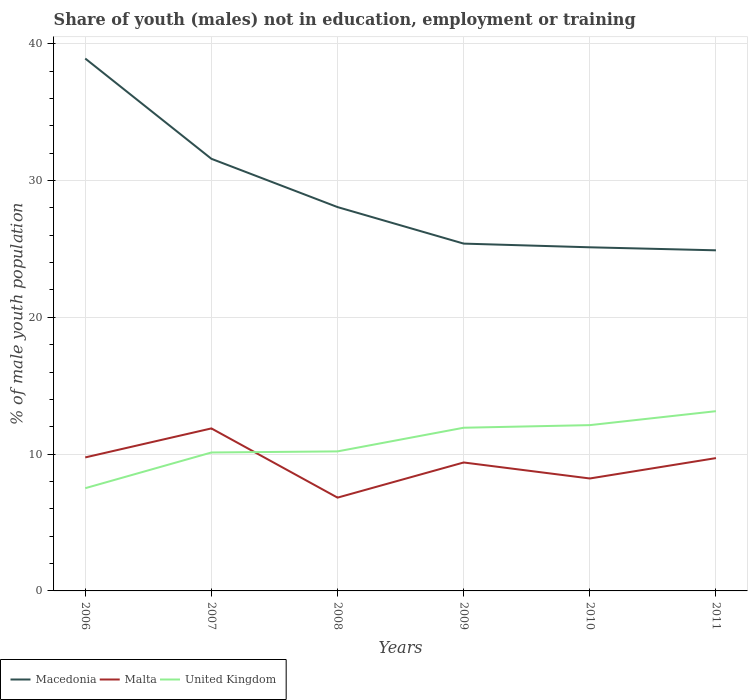Is the number of lines equal to the number of legend labels?
Make the answer very short. Yes. Across all years, what is the maximum percentage of unemployed males population in in Macedonia?
Your answer should be compact. 24.9. What is the total percentage of unemployed males population in in United Kingdom in the graph?
Offer a very short reply. -1.81. What is the difference between the highest and the second highest percentage of unemployed males population in in Macedonia?
Offer a terse response. 14.02. How many legend labels are there?
Provide a short and direct response. 3. What is the title of the graph?
Your response must be concise. Share of youth (males) not in education, employment or training. What is the label or title of the X-axis?
Ensure brevity in your answer.  Years. What is the label or title of the Y-axis?
Provide a short and direct response. % of male youth population. What is the % of male youth population of Macedonia in 2006?
Provide a succinct answer. 38.92. What is the % of male youth population in Malta in 2006?
Offer a terse response. 9.76. What is the % of male youth population in United Kingdom in 2006?
Provide a short and direct response. 7.51. What is the % of male youth population of Macedonia in 2007?
Ensure brevity in your answer.  31.59. What is the % of male youth population in Malta in 2007?
Your answer should be compact. 11.88. What is the % of male youth population of United Kingdom in 2007?
Ensure brevity in your answer.  10.12. What is the % of male youth population of Macedonia in 2008?
Ensure brevity in your answer.  28.06. What is the % of male youth population of Malta in 2008?
Your answer should be very brief. 6.82. What is the % of male youth population of United Kingdom in 2008?
Ensure brevity in your answer.  10.2. What is the % of male youth population in Macedonia in 2009?
Offer a terse response. 25.39. What is the % of male youth population in Malta in 2009?
Ensure brevity in your answer.  9.39. What is the % of male youth population in United Kingdom in 2009?
Your answer should be compact. 11.93. What is the % of male youth population of Macedonia in 2010?
Give a very brief answer. 25.12. What is the % of male youth population of Malta in 2010?
Offer a terse response. 8.22. What is the % of male youth population in United Kingdom in 2010?
Provide a short and direct response. 12.12. What is the % of male youth population in Macedonia in 2011?
Ensure brevity in your answer.  24.9. What is the % of male youth population in Malta in 2011?
Ensure brevity in your answer.  9.71. What is the % of male youth population of United Kingdom in 2011?
Offer a very short reply. 13.14. Across all years, what is the maximum % of male youth population in Macedonia?
Ensure brevity in your answer.  38.92. Across all years, what is the maximum % of male youth population of Malta?
Your answer should be compact. 11.88. Across all years, what is the maximum % of male youth population in United Kingdom?
Give a very brief answer. 13.14. Across all years, what is the minimum % of male youth population of Macedonia?
Your answer should be very brief. 24.9. Across all years, what is the minimum % of male youth population of Malta?
Your answer should be compact. 6.82. Across all years, what is the minimum % of male youth population of United Kingdom?
Provide a short and direct response. 7.51. What is the total % of male youth population of Macedonia in the graph?
Your response must be concise. 173.98. What is the total % of male youth population of Malta in the graph?
Your response must be concise. 55.78. What is the total % of male youth population of United Kingdom in the graph?
Your answer should be very brief. 65.02. What is the difference between the % of male youth population of Macedonia in 2006 and that in 2007?
Provide a succinct answer. 7.33. What is the difference between the % of male youth population of Malta in 2006 and that in 2007?
Ensure brevity in your answer.  -2.12. What is the difference between the % of male youth population in United Kingdom in 2006 and that in 2007?
Provide a short and direct response. -2.61. What is the difference between the % of male youth population of Macedonia in 2006 and that in 2008?
Ensure brevity in your answer.  10.86. What is the difference between the % of male youth population in Malta in 2006 and that in 2008?
Provide a short and direct response. 2.94. What is the difference between the % of male youth population of United Kingdom in 2006 and that in 2008?
Your response must be concise. -2.69. What is the difference between the % of male youth population in Macedonia in 2006 and that in 2009?
Your answer should be very brief. 13.53. What is the difference between the % of male youth population in Malta in 2006 and that in 2009?
Provide a succinct answer. 0.37. What is the difference between the % of male youth population in United Kingdom in 2006 and that in 2009?
Provide a short and direct response. -4.42. What is the difference between the % of male youth population in Macedonia in 2006 and that in 2010?
Your answer should be very brief. 13.8. What is the difference between the % of male youth population of Malta in 2006 and that in 2010?
Provide a short and direct response. 1.54. What is the difference between the % of male youth population of United Kingdom in 2006 and that in 2010?
Give a very brief answer. -4.61. What is the difference between the % of male youth population in Macedonia in 2006 and that in 2011?
Your response must be concise. 14.02. What is the difference between the % of male youth population in United Kingdom in 2006 and that in 2011?
Your response must be concise. -5.63. What is the difference between the % of male youth population in Macedonia in 2007 and that in 2008?
Your answer should be very brief. 3.53. What is the difference between the % of male youth population of Malta in 2007 and that in 2008?
Offer a very short reply. 5.06. What is the difference between the % of male youth population of United Kingdom in 2007 and that in 2008?
Keep it short and to the point. -0.08. What is the difference between the % of male youth population of Macedonia in 2007 and that in 2009?
Your response must be concise. 6.2. What is the difference between the % of male youth population of Malta in 2007 and that in 2009?
Offer a terse response. 2.49. What is the difference between the % of male youth population in United Kingdom in 2007 and that in 2009?
Make the answer very short. -1.81. What is the difference between the % of male youth population of Macedonia in 2007 and that in 2010?
Ensure brevity in your answer.  6.47. What is the difference between the % of male youth population in Malta in 2007 and that in 2010?
Give a very brief answer. 3.66. What is the difference between the % of male youth population of Macedonia in 2007 and that in 2011?
Offer a very short reply. 6.69. What is the difference between the % of male youth population in Malta in 2007 and that in 2011?
Keep it short and to the point. 2.17. What is the difference between the % of male youth population in United Kingdom in 2007 and that in 2011?
Offer a terse response. -3.02. What is the difference between the % of male youth population of Macedonia in 2008 and that in 2009?
Your answer should be compact. 2.67. What is the difference between the % of male youth population of Malta in 2008 and that in 2009?
Provide a succinct answer. -2.57. What is the difference between the % of male youth population of United Kingdom in 2008 and that in 2009?
Offer a terse response. -1.73. What is the difference between the % of male youth population in Macedonia in 2008 and that in 2010?
Provide a short and direct response. 2.94. What is the difference between the % of male youth population of Malta in 2008 and that in 2010?
Make the answer very short. -1.4. What is the difference between the % of male youth population of United Kingdom in 2008 and that in 2010?
Provide a succinct answer. -1.92. What is the difference between the % of male youth population of Macedonia in 2008 and that in 2011?
Offer a terse response. 3.16. What is the difference between the % of male youth population of Malta in 2008 and that in 2011?
Your answer should be compact. -2.89. What is the difference between the % of male youth population in United Kingdom in 2008 and that in 2011?
Provide a succinct answer. -2.94. What is the difference between the % of male youth population of Macedonia in 2009 and that in 2010?
Offer a terse response. 0.27. What is the difference between the % of male youth population of Malta in 2009 and that in 2010?
Ensure brevity in your answer.  1.17. What is the difference between the % of male youth population of United Kingdom in 2009 and that in 2010?
Make the answer very short. -0.19. What is the difference between the % of male youth population of Macedonia in 2009 and that in 2011?
Keep it short and to the point. 0.49. What is the difference between the % of male youth population of Malta in 2009 and that in 2011?
Your answer should be very brief. -0.32. What is the difference between the % of male youth population of United Kingdom in 2009 and that in 2011?
Your response must be concise. -1.21. What is the difference between the % of male youth population of Macedonia in 2010 and that in 2011?
Ensure brevity in your answer.  0.22. What is the difference between the % of male youth population in Malta in 2010 and that in 2011?
Provide a succinct answer. -1.49. What is the difference between the % of male youth population in United Kingdom in 2010 and that in 2011?
Provide a succinct answer. -1.02. What is the difference between the % of male youth population in Macedonia in 2006 and the % of male youth population in Malta in 2007?
Give a very brief answer. 27.04. What is the difference between the % of male youth population of Macedonia in 2006 and the % of male youth population of United Kingdom in 2007?
Your response must be concise. 28.8. What is the difference between the % of male youth population in Malta in 2006 and the % of male youth population in United Kingdom in 2007?
Your response must be concise. -0.36. What is the difference between the % of male youth population of Macedonia in 2006 and the % of male youth population of Malta in 2008?
Make the answer very short. 32.1. What is the difference between the % of male youth population of Macedonia in 2006 and the % of male youth population of United Kingdom in 2008?
Ensure brevity in your answer.  28.72. What is the difference between the % of male youth population in Malta in 2006 and the % of male youth population in United Kingdom in 2008?
Give a very brief answer. -0.44. What is the difference between the % of male youth population of Macedonia in 2006 and the % of male youth population of Malta in 2009?
Ensure brevity in your answer.  29.53. What is the difference between the % of male youth population in Macedonia in 2006 and the % of male youth population in United Kingdom in 2009?
Your answer should be compact. 26.99. What is the difference between the % of male youth population of Malta in 2006 and the % of male youth population of United Kingdom in 2009?
Make the answer very short. -2.17. What is the difference between the % of male youth population in Macedonia in 2006 and the % of male youth population in Malta in 2010?
Your response must be concise. 30.7. What is the difference between the % of male youth population in Macedonia in 2006 and the % of male youth population in United Kingdom in 2010?
Keep it short and to the point. 26.8. What is the difference between the % of male youth population in Malta in 2006 and the % of male youth population in United Kingdom in 2010?
Provide a succinct answer. -2.36. What is the difference between the % of male youth population of Macedonia in 2006 and the % of male youth population of Malta in 2011?
Ensure brevity in your answer.  29.21. What is the difference between the % of male youth population of Macedonia in 2006 and the % of male youth population of United Kingdom in 2011?
Your answer should be compact. 25.78. What is the difference between the % of male youth population in Malta in 2006 and the % of male youth population in United Kingdom in 2011?
Your answer should be compact. -3.38. What is the difference between the % of male youth population of Macedonia in 2007 and the % of male youth population of Malta in 2008?
Your response must be concise. 24.77. What is the difference between the % of male youth population of Macedonia in 2007 and the % of male youth population of United Kingdom in 2008?
Ensure brevity in your answer.  21.39. What is the difference between the % of male youth population in Malta in 2007 and the % of male youth population in United Kingdom in 2008?
Offer a terse response. 1.68. What is the difference between the % of male youth population of Macedonia in 2007 and the % of male youth population of United Kingdom in 2009?
Offer a very short reply. 19.66. What is the difference between the % of male youth population of Macedonia in 2007 and the % of male youth population of Malta in 2010?
Keep it short and to the point. 23.37. What is the difference between the % of male youth population of Macedonia in 2007 and the % of male youth population of United Kingdom in 2010?
Give a very brief answer. 19.47. What is the difference between the % of male youth population in Malta in 2007 and the % of male youth population in United Kingdom in 2010?
Your answer should be very brief. -0.24. What is the difference between the % of male youth population of Macedonia in 2007 and the % of male youth population of Malta in 2011?
Offer a terse response. 21.88. What is the difference between the % of male youth population of Macedonia in 2007 and the % of male youth population of United Kingdom in 2011?
Keep it short and to the point. 18.45. What is the difference between the % of male youth population in Malta in 2007 and the % of male youth population in United Kingdom in 2011?
Provide a succinct answer. -1.26. What is the difference between the % of male youth population in Macedonia in 2008 and the % of male youth population in Malta in 2009?
Make the answer very short. 18.67. What is the difference between the % of male youth population in Macedonia in 2008 and the % of male youth population in United Kingdom in 2009?
Provide a succinct answer. 16.13. What is the difference between the % of male youth population in Malta in 2008 and the % of male youth population in United Kingdom in 2009?
Offer a terse response. -5.11. What is the difference between the % of male youth population in Macedonia in 2008 and the % of male youth population in Malta in 2010?
Give a very brief answer. 19.84. What is the difference between the % of male youth population of Macedonia in 2008 and the % of male youth population of United Kingdom in 2010?
Your response must be concise. 15.94. What is the difference between the % of male youth population of Malta in 2008 and the % of male youth population of United Kingdom in 2010?
Give a very brief answer. -5.3. What is the difference between the % of male youth population in Macedonia in 2008 and the % of male youth population in Malta in 2011?
Provide a short and direct response. 18.35. What is the difference between the % of male youth population in Macedonia in 2008 and the % of male youth population in United Kingdom in 2011?
Provide a succinct answer. 14.92. What is the difference between the % of male youth population in Malta in 2008 and the % of male youth population in United Kingdom in 2011?
Keep it short and to the point. -6.32. What is the difference between the % of male youth population of Macedonia in 2009 and the % of male youth population of Malta in 2010?
Ensure brevity in your answer.  17.17. What is the difference between the % of male youth population of Macedonia in 2009 and the % of male youth population of United Kingdom in 2010?
Provide a short and direct response. 13.27. What is the difference between the % of male youth population of Malta in 2009 and the % of male youth population of United Kingdom in 2010?
Keep it short and to the point. -2.73. What is the difference between the % of male youth population of Macedonia in 2009 and the % of male youth population of Malta in 2011?
Your answer should be very brief. 15.68. What is the difference between the % of male youth population in Macedonia in 2009 and the % of male youth population in United Kingdom in 2011?
Offer a very short reply. 12.25. What is the difference between the % of male youth population of Malta in 2009 and the % of male youth population of United Kingdom in 2011?
Offer a terse response. -3.75. What is the difference between the % of male youth population in Macedonia in 2010 and the % of male youth population in Malta in 2011?
Offer a terse response. 15.41. What is the difference between the % of male youth population of Macedonia in 2010 and the % of male youth population of United Kingdom in 2011?
Provide a succinct answer. 11.98. What is the difference between the % of male youth population in Malta in 2010 and the % of male youth population in United Kingdom in 2011?
Your answer should be very brief. -4.92. What is the average % of male youth population in Macedonia per year?
Offer a terse response. 29. What is the average % of male youth population in Malta per year?
Your answer should be very brief. 9.3. What is the average % of male youth population of United Kingdom per year?
Your response must be concise. 10.84. In the year 2006, what is the difference between the % of male youth population of Macedonia and % of male youth population of Malta?
Make the answer very short. 29.16. In the year 2006, what is the difference between the % of male youth population of Macedonia and % of male youth population of United Kingdom?
Keep it short and to the point. 31.41. In the year 2006, what is the difference between the % of male youth population in Malta and % of male youth population in United Kingdom?
Ensure brevity in your answer.  2.25. In the year 2007, what is the difference between the % of male youth population in Macedonia and % of male youth population in Malta?
Your answer should be very brief. 19.71. In the year 2007, what is the difference between the % of male youth population in Macedonia and % of male youth population in United Kingdom?
Offer a terse response. 21.47. In the year 2007, what is the difference between the % of male youth population in Malta and % of male youth population in United Kingdom?
Offer a very short reply. 1.76. In the year 2008, what is the difference between the % of male youth population of Macedonia and % of male youth population of Malta?
Your answer should be compact. 21.24. In the year 2008, what is the difference between the % of male youth population in Macedonia and % of male youth population in United Kingdom?
Offer a terse response. 17.86. In the year 2008, what is the difference between the % of male youth population in Malta and % of male youth population in United Kingdom?
Your answer should be very brief. -3.38. In the year 2009, what is the difference between the % of male youth population of Macedonia and % of male youth population of Malta?
Provide a succinct answer. 16. In the year 2009, what is the difference between the % of male youth population in Macedonia and % of male youth population in United Kingdom?
Your answer should be very brief. 13.46. In the year 2009, what is the difference between the % of male youth population of Malta and % of male youth population of United Kingdom?
Provide a succinct answer. -2.54. In the year 2010, what is the difference between the % of male youth population in Macedonia and % of male youth population in Malta?
Make the answer very short. 16.9. In the year 2011, what is the difference between the % of male youth population in Macedonia and % of male youth population in Malta?
Provide a short and direct response. 15.19. In the year 2011, what is the difference between the % of male youth population of Macedonia and % of male youth population of United Kingdom?
Give a very brief answer. 11.76. In the year 2011, what is the difference between the % of male youth population of Malta and % of male youth population of United Kingdom?
Your answer should be compact. -3.43. What is the ratio of the % of male youth population in Macedonia in 2006 to that in 2007?
Your answer should be very brief. 1.23. What is the ratio of the % of male youth population of Malta in 2006 to that in 2007?
Provide a short and direct response. 0.82. What is the ratio of the % of male youth population of United Kingdom in 2006 to that in 2007?
Your answer should be compact. 0.74. What is the ratio of the % of male youth population of Macedonia in 2006 to that in 2008?
Provide a short and direct response. 1.39. What is the ratio of the % of male youth population in Malta in 2006 to that in 2008?
Offer a terse response. 1.43. What is the ratio of the % of male youth population in United Kingdom in 2006 to that in 2008?
Offer a terse response. 0.74. What is the ratio of the % of male youth population in Macedonia in 2006 to that in 2009?
Offer a very short reply. 1.53. What is the ratio of the % of male youth population in Malta in 2006 to that in 2009?
Keep it short and to the point. 1.04. What is the ratio of the % of male youth population of United Kingdom in 2006 to that in 2009?
Offer a terse response. 0.63. What is the ratio of the % of male youth population of Macedonia in 2006 to that in 2010?
Make the answer very short. 1.55. What is the ratio of the % of male youth population in Malta in 2006 to that in 2010?
Give a very brief answer. 1.19. What is the ratio of the % of male youth population of United Kingdom in 2006 to that in 2010?
Give a very brief answer. 0.62. What is the ratio of the % of male youth population in Macedonia in 2006 to that in 2011?
Keep it short and to the point. 1.56. What is the ratio of the % of male youth population of Malta in 2006 to that in 2011?
Offer a terse response. 1.01. What is the ratio of the % of male youth population in United Kingdom in 2006 to that in 2011?
Offer a very short reply. 0.57. What is the ratio of the % of male youth population in Macedonia in 2007 to that in 2008?
Your answer should be very brief. 1.13. What is the ratio of the % of male youth population of Malta in 2007 to that in 2008?
Give a very brief answer. 1.74. What is the ratio of the % of male youth population of Macedonia in 2007 to that in 2009?
Your response must be concise. 1.24. What is the ratio of the % of male youth population in Malta in 2007 to that in 2009?
Your answer should be very brief. 1.27. What is the ratio of the % of male youth population in United Kingdom in 2007 to that in 2009?
Give a very brief answer. 0.85. What is the ratio of the % of male youth population in Macedonia in 2007 to that in 2010?
Your answer should be compact. 1.26. What is the ratio of the % of male youth population of Malta in 2007 to that in 2010?
Your response must be concise. 1.45. What is the ratio of the % of male youth population of United Kingdom in 2007 to that in 2010?
Your response must be concise. 0.83. What is the ratio of the % of male youth population of Macedonia in 2007 to that in 2011?
Give a very brief answer. 1.27. What is the ratio of the % of male youth population in Malta in 2007 to that in 2011?
Offer a very short reply. 1.22. What is the ratio of the % of male youth population of United Kingdom in 2007 to that in 2011?
Make the answer very short. 0.77. What is the ratio of the % of male youth population in Macedonia in 2008 to that in 2009?
Your response must be concise. 1.11. What is the ratio of the % of male youth population in Malta in 2008 to that in 2009?
Your response must be concise. 0.73. What is the ratio of the % of male youth population in United Kingdom in 2008 to that in 2009?
Your answer should be very brief. 0.85. What is the ratio of the % of male youth population of Macedonia in 2008 to that in 2010?
Keep it short and to the point. 1.12. What is the ratio of the % of male youth population of Malta in 2008 to that in 2010?
Give a very brief answer. 0.83. What is the ratio of the % of male youth population in United Kingdom in 2008 to that in 2010?
Ensure brevity in your answer.  0.84. What is the ratio of the % of male youth population of Macedonia in 2008 to that in 2011?
Keep it short and to the point. 1.13. What is the ratio of the % of male youth population in Malta in 2008 to that in 2011?
Your answer should be very brief. 0.7. What is the ratio of the % of male youth population in United Kingdom in 2008 to that in 2011?
Your answer should be compact. 0.78. What is the ratio of the % of male youth population in Macedonia in 2009 to that in 2010?
Keep it short and to the point. 1.01. What is the ratio of the % of male youth population in Malta in 2009 to that in 2010?
Make the answer very short. 1.14. What is the ratio of the % of male youth population of United Kingdom in 2009 to that in 2010?
Your response must be concise. 0.98. What is the ratio of the % of male youth population of Macedonia in 2009 to that in 2011?
Offer a terse response. 1.02. What is the ratio of the % of male youth population of United Kingdom in 2009 to that in 2011?
Provide a short and direct response. 0.91. What is the ratio of the % of male youth population of Macedonia in 2010 to that in 2011?
Your answer should be compact. 1.01. What is the ratio of the % of male youth population of Malta in 2010 to that in 2011?
Provide a short and direct response. 0.85. What is the ratio of the % of male youth population of United Kingdom in 2010 to that in 2011?
Offer a very short reply. 0.92. What is the difference between the highest and the second highest % of male youth population in Macedonia?
Ensure brevity in your answer.  7.33. What is the difference between the highest and the second highest % of male youth population in Malta?
Ensure brevity in your answer.  2.12. What is the difference between the highest and the lowest % of male youth population of Macedonia?
Offer a terse response. 14.02. What is the difference between the highest and the lowest % of male youth population of Malta?
Provide a succinct answer. 5.06. What is the difference between the highest and the lowest % of male youth population of United Kingdom?
Make the answer very short. 5.63. 